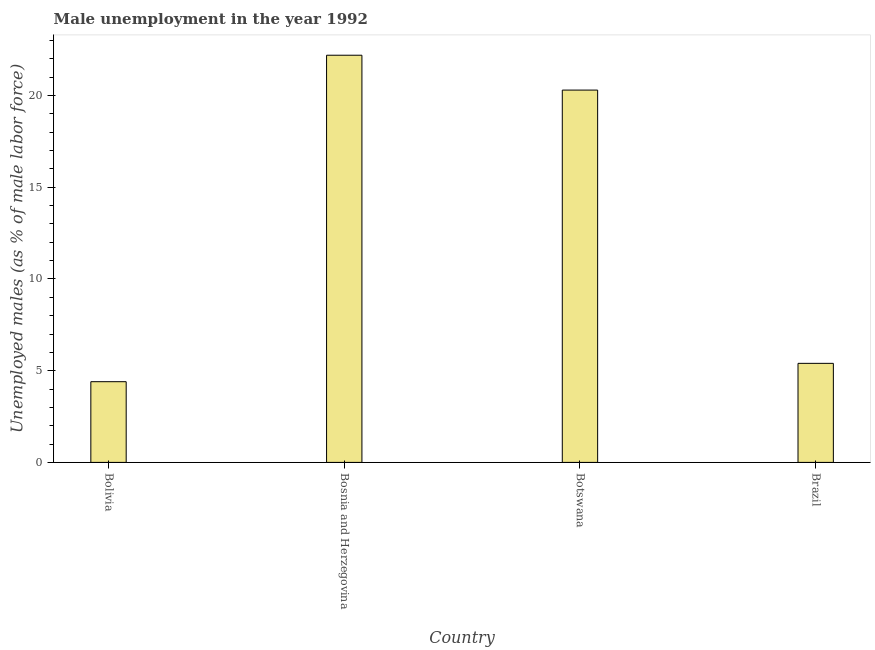Does the graph contain any zero values?
Ensure brevity in your answer.  No. What is the title of the graph?
Your answer should be compact. Male unemployment in the year 1992. What is the label or title of the Y-axis?
Make the answer very short. Unemployed males (as % of male labor force). What is the unemployed males population in Brazil?
Ensure brevity in your answer.  5.4. Across all countries, what is the maximum unemployed males population?
Make the answer very short. 22.2. Across all countries, what is the minimum unemployed males population?
Offer a very short reply. 4.4. In which country was the unemployed males population maximum?
Your response must be concise. Bosnia and Herzegovina. What is the sum of the unemployed males population?
Your answer should be very brief. 52.3. What is the difference between the unemployed males population in Bosnia and Herzegovina and Botswana?
Keep it short and to the point. 1.9. What is the average unemployed males population per country?
Your answer should be very brief. 13.07. What is the median unemployed males population?
Provide a short and direct response. 12.85. What is the ratio of the unemployed males population in Bolivia to that in Brazil?
Offer a terse response. 0.81. In how many countries, is the unemployed males population greater than the average unemployed males population taken over all countries?
Provide a succinct answer. 2. How many bars are there?
Ensure brevity in your answer.  4. Are all the bars in the graph horizontal?
Your answer should be compact. No. What is the Unemployed males (as % of male labor force) of Bolivia?
Offer a very short reply. 4.4. What is the Unemployed males (as % of male labor force) of Bosnia and Herzegovina?
Make the answer very short. 22.2. What is the Unemployed males (as % of male labor force) of Botswana?
Ensure brevity in your answer.  20.3. What is the Unemployed males (as % of male labor force) of Brazil?
Offer a terse response. 5.4. What is the difference between the Unemployed males (as % of male labor force) in Bolivia and Bosnia and Herzegovina?
Your answer should be compact. -17.8. What is the difference between the Unemployed males (as % of male labor force) in Bolivia and Botswana?
Offer a terse response. -15.9. What is the difference between the Unemployed males (as % of male labor force) in Botswana and Brazil?
Provide a short and direct response. 14.9. What is the ratio of the Unemployed males (as % of male labor force) in Bolivia to that in Bosnia and Herzegovina?
Ensure brevity in your answer.  0.2. What is the ratio of the Unemployed males (as % of male labor force) in Bolivia to that in Botswana?
Keep it short and to the point. 0.22. What is the ratio of the Unemployed males (as % of male labor force) in Bolivia to that in Brazil?
Your answer should be very brief. 0.81. What is the ratio of the Unemployed males (as % of male labor force) in Bosnia and Herzegovina to that in Botswana?
Provide a succinct answer. 1.09. What is the ratio of the Unemployed males (as % of male labor force) in Bosnia and Herzegovina to that in Brazil?
Keep it short and to the point. 4.11. What is the ratio of the Unemployed males (as % of male labor force) in Botswana to that in Brazil?
Provide a succinct answer. 3.76. 